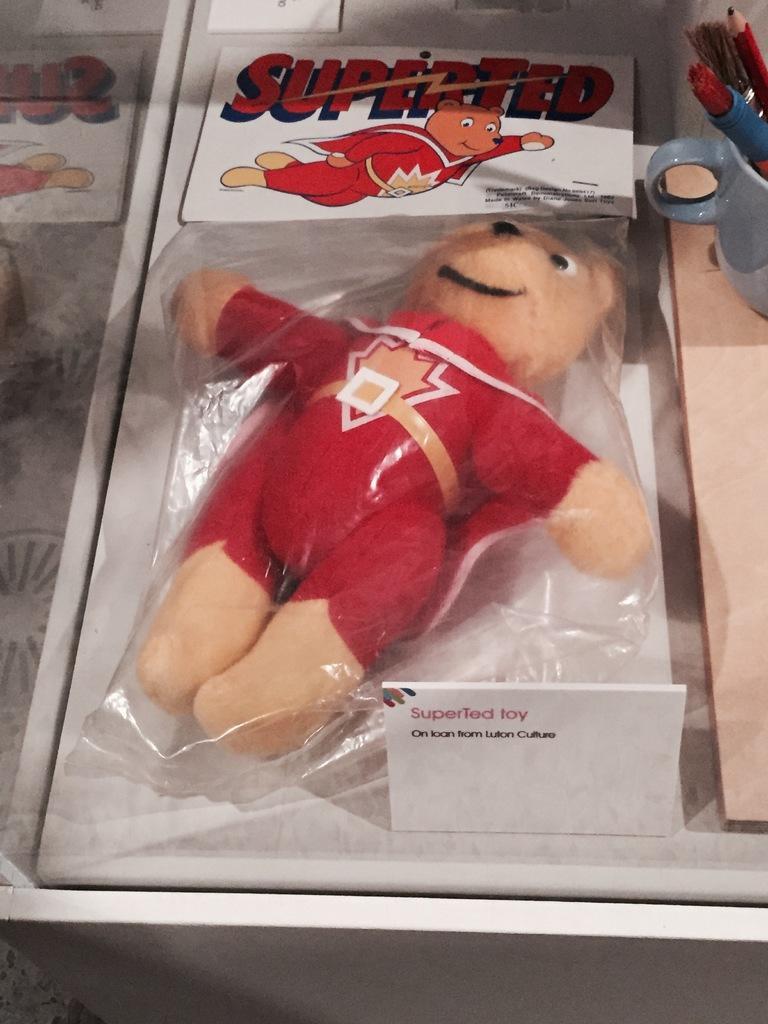Could you give a brief overview of what you see in this image? In this image in the center there is one toy which is packed, and there is one board. On the board there is some text, on the left side there is one table. On the table there is one cup, in that cup there are some brushes and a pencil. 